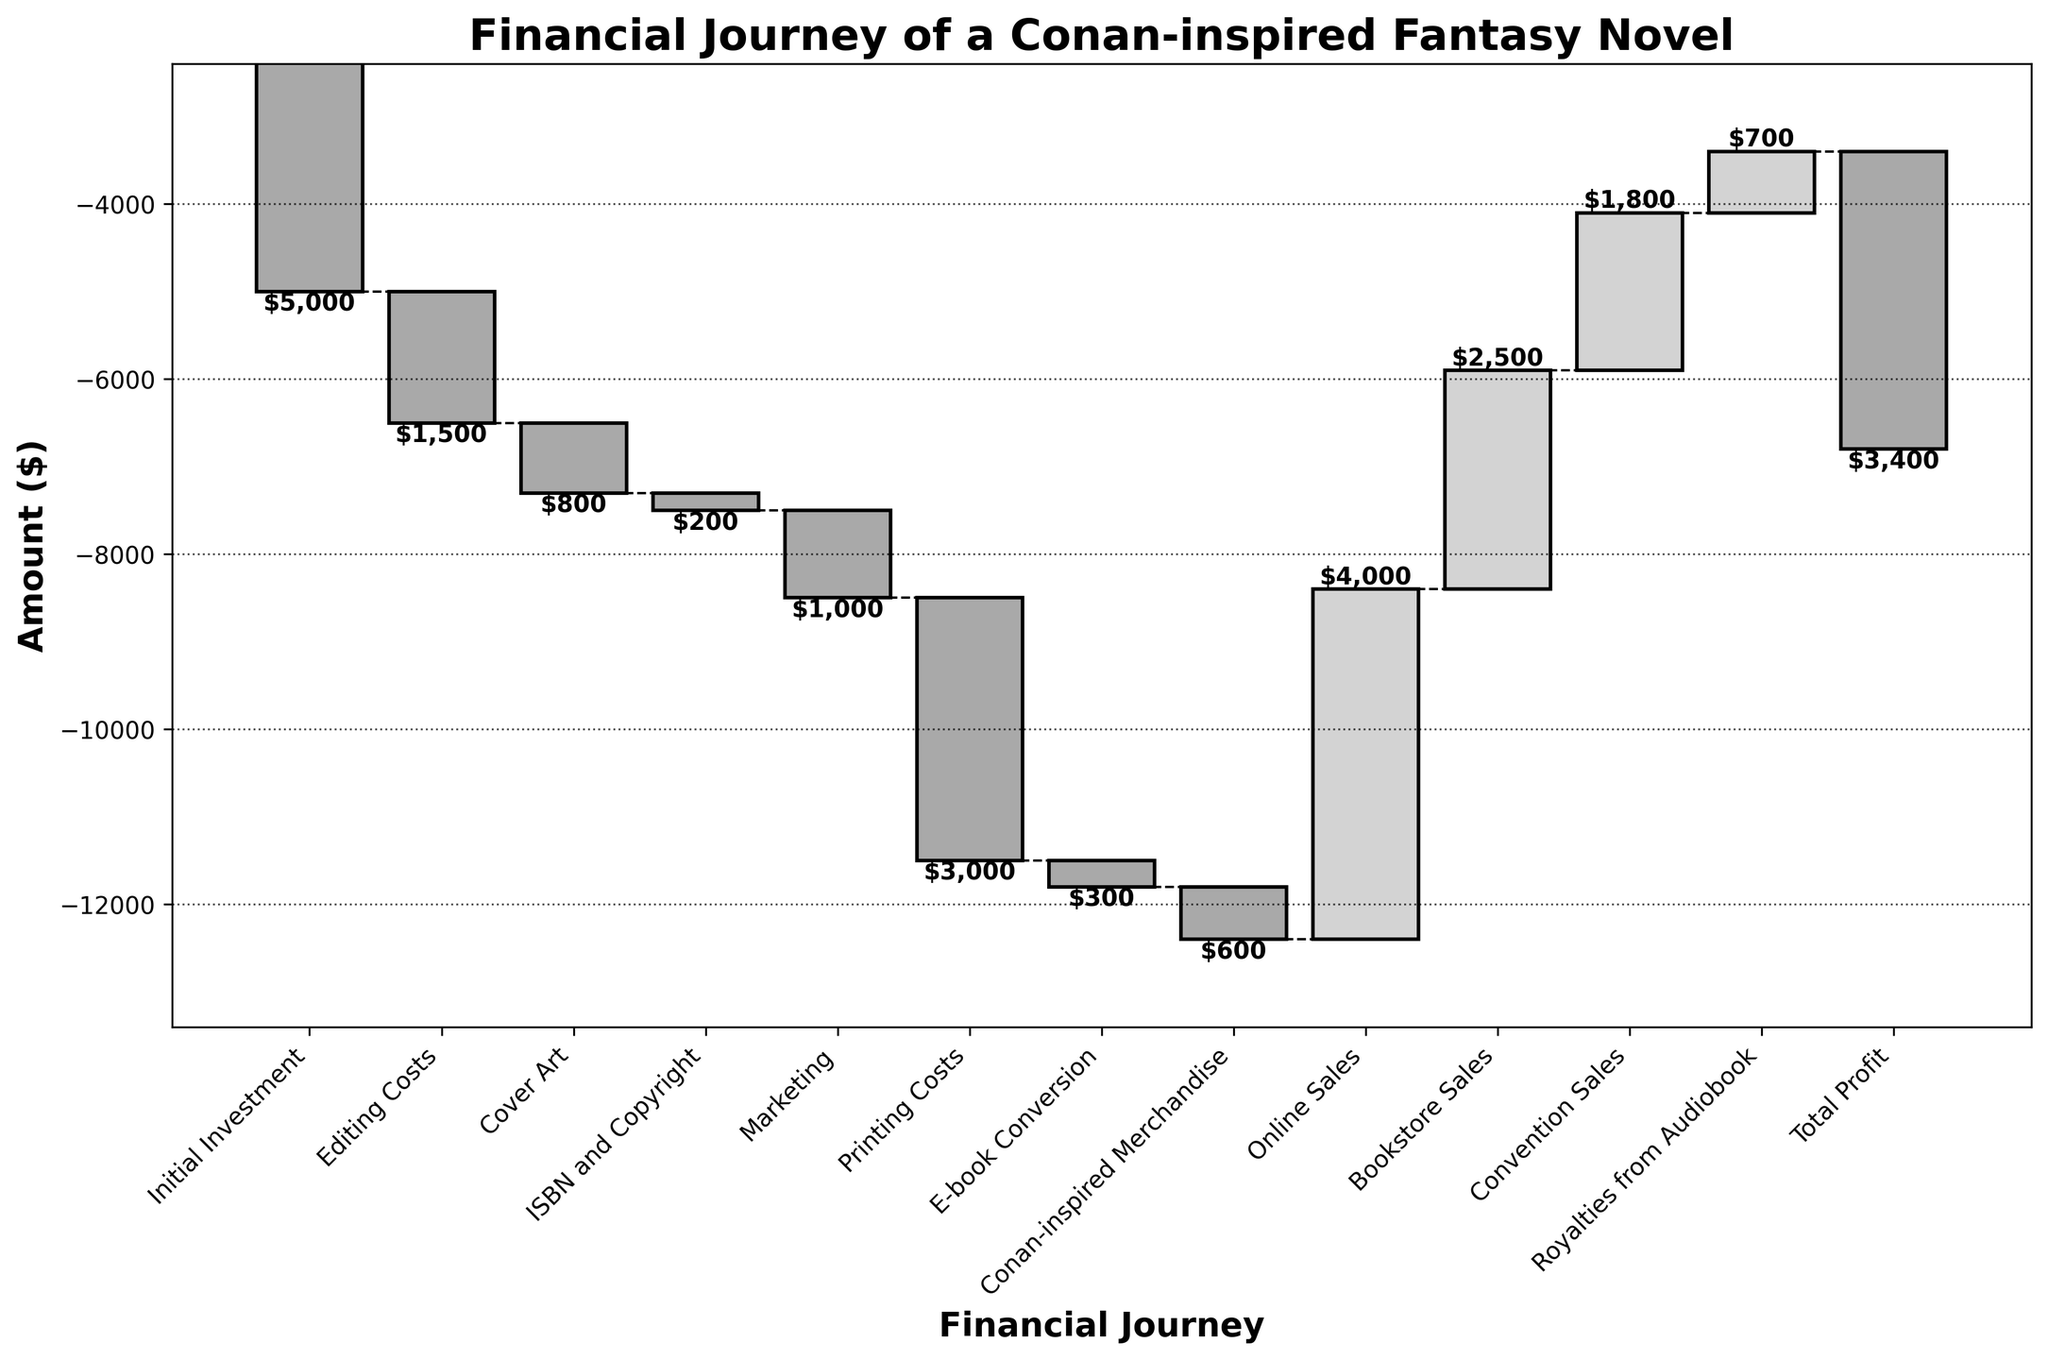What's the total amount spent on marketing? The "Marketing" bar on the chart shows the expenditure, which can be read directly as -1000 dollars.
Answer: -1000 How does the total printing cost compare to the cost of editing? By comparing the "Printing Costs" bar (-3000) to the "Editing Costs" bar (-1500), we see the printing costs are higher.
Answer: Printing costs are higher What is the final total profit or loss for the novel? The "Total Profit" bar is the last one on the chart, showing -3400.
Answer: -3400 Which revenue source contributes the most to the income? Check the heights of the positive (upward) bars. "Online Sales" has the highest value, at 4000 dollars.
Answer: Online Sales How much is spent on e-book conversion? The "E-book Conversion" bar on the chart shows an expenditure of -300 dollars.
Answer: -300 What is the sum of all the initial costs (excluding sales revenue)? Add up the amounts for Initial Investment (-5000), Editing Costs (-1500), Cover Art (-800), ISBN and Copyright (-200), Marketing (-1000), Printing Costs (-3000), E-book Conversion (-300), and Conan-inspired Merchandise (-600): -5000 - 1500 - 800 - 200 - 1000 - 3000 - 300 - 600 = -12400 dollars.
Answer: -12400 Which category immediately follows "Cover Art" in the financial journey? The next category after "Cover Art" (third bar) is "ISBN and Copyright" (fourth bar).
Answer: ISBN and Copyright What is the cumulative value after accounting for marketing expenditures? The cumulative value until the marketing expenditures is calculated by summing Initial Investment (-5000), Editing Costs (-1500), Cover Art (-800), ISBN and Copyright (-200), and Marketing (-1000): -5000 - 1500 - 800 - 200 - 1000 = -8500 dollars.
Answer: -8500 If you combine all the sales-related revenues, what is the total amount? Add up the amounts for Online Sales (4000), Bookstore Sales (2500), Convention Sales (1800), and Royalties from Audiobook (700): 4000 + 2500 + 1800 + 700 = 9000 dollars.
Answer: 9000 What is the difference between the total earnings from convention sales and the expenditure on Conan-inspired merchandise? Subtract the amount spent on Conan-inspired Merchandise (-600) from Convention Sales (1800): 1800 - (-600) = 1800 + 600 = 2400 dollars.
Answer: 2400 